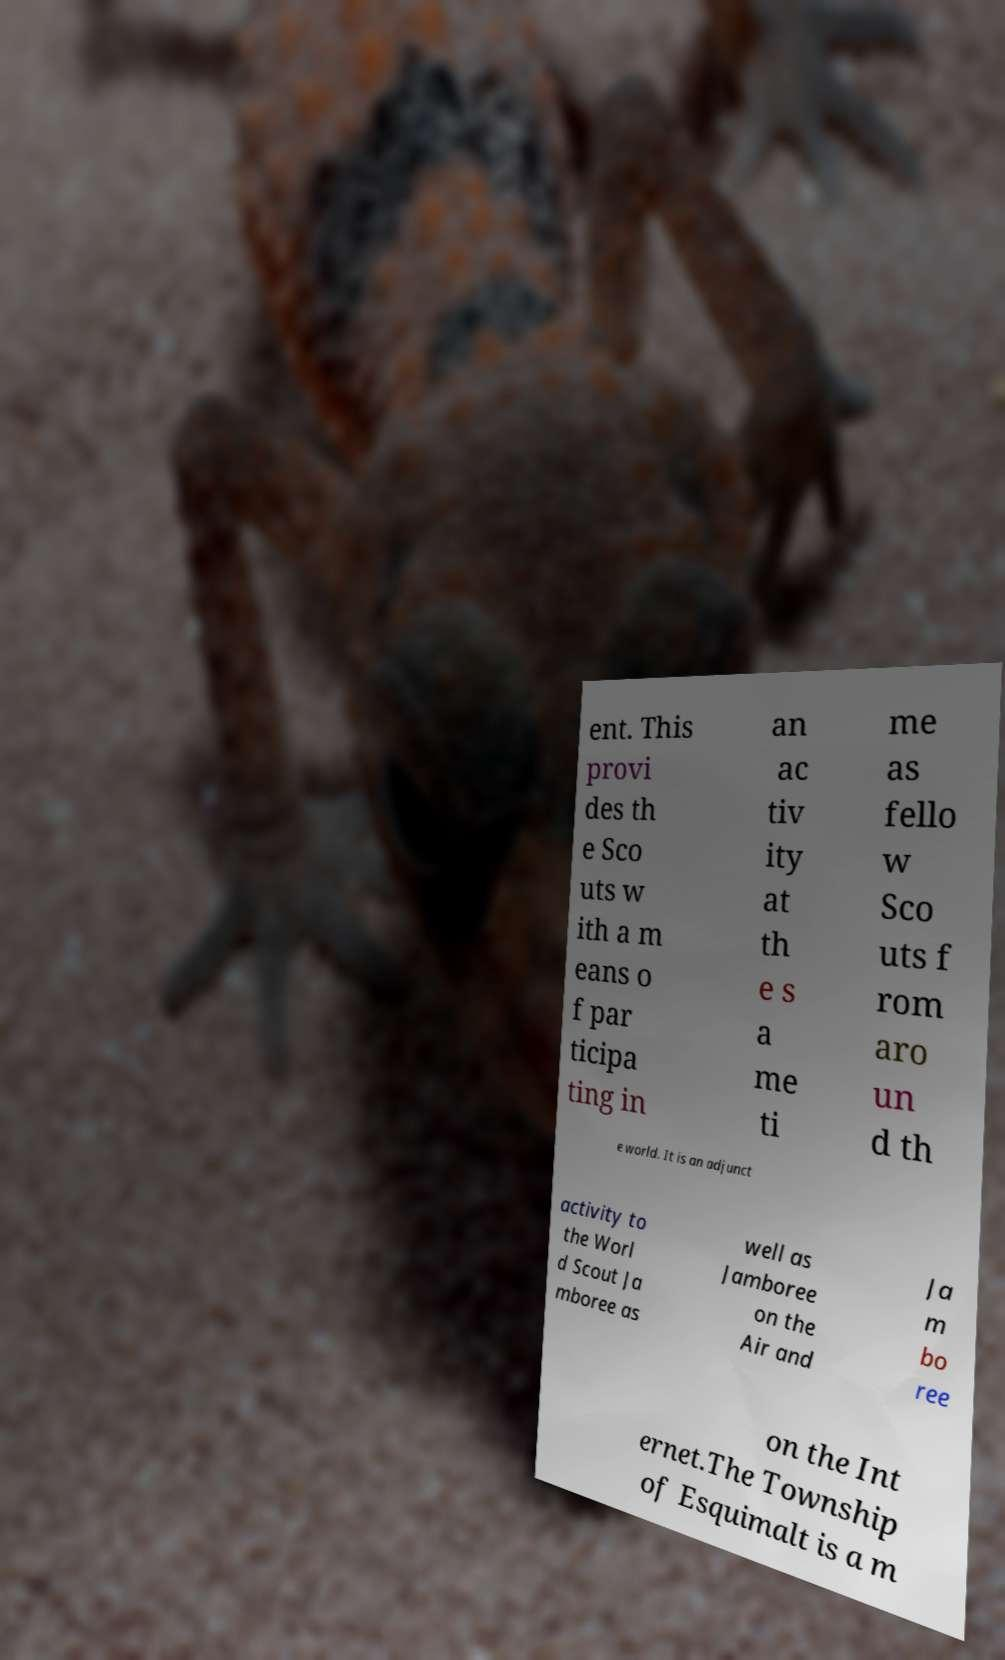Could you assist in decoding the text presented in this image and type it out clearly? ent. This provi des th e Sco uts w ith a m eans o f par ticipa ting in an ac tiv ity at th e s a me ti me as fello w Sco uts f rom aro un d th e world. It is an adjunct activity to the Worl d Scout Ja mboree as well as Jamboree on the Air and Ja m bo ree on the Int ernet.The Township of Esquimalt is a m 